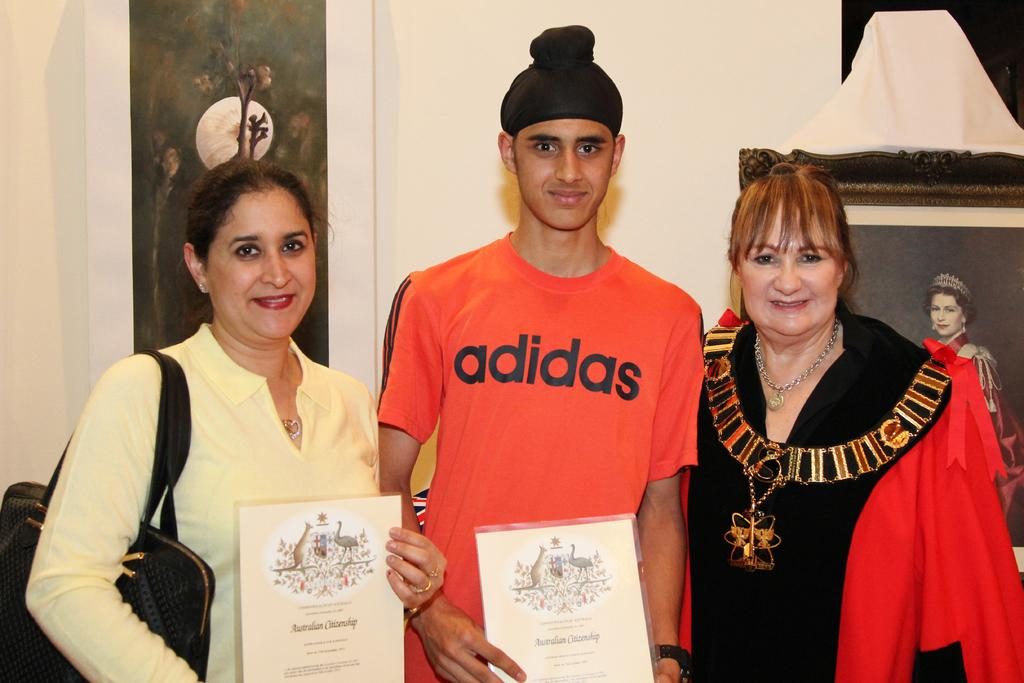How many people are in the image? There are three persons in the image. What are the expressions on their faces? The persons are smiling. What are two of the persons holding in their hands? They are holding a memo in their hands. What can be seen in the background of the image? There are photo frames hanging on the wall in the background. What type of knot is being tied by the person in the image? There is no person tying a knot in the image. How many buttons can be seen on the shirt of the person in the image? There is no person wearing a shirt with buttons in the image. 